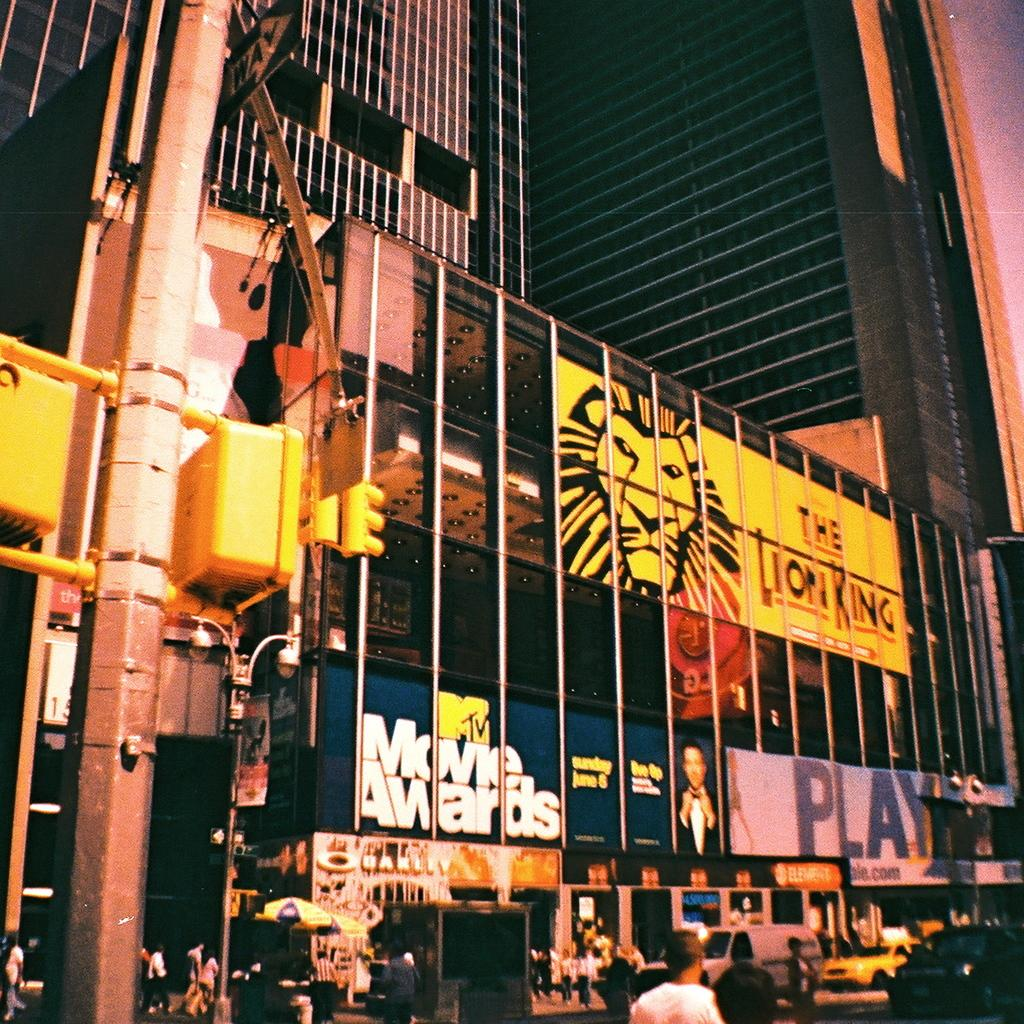<image>
Relay a brief, clear account of the picture shown. Huge building outside advertising upcoming events especially the Lion King. 